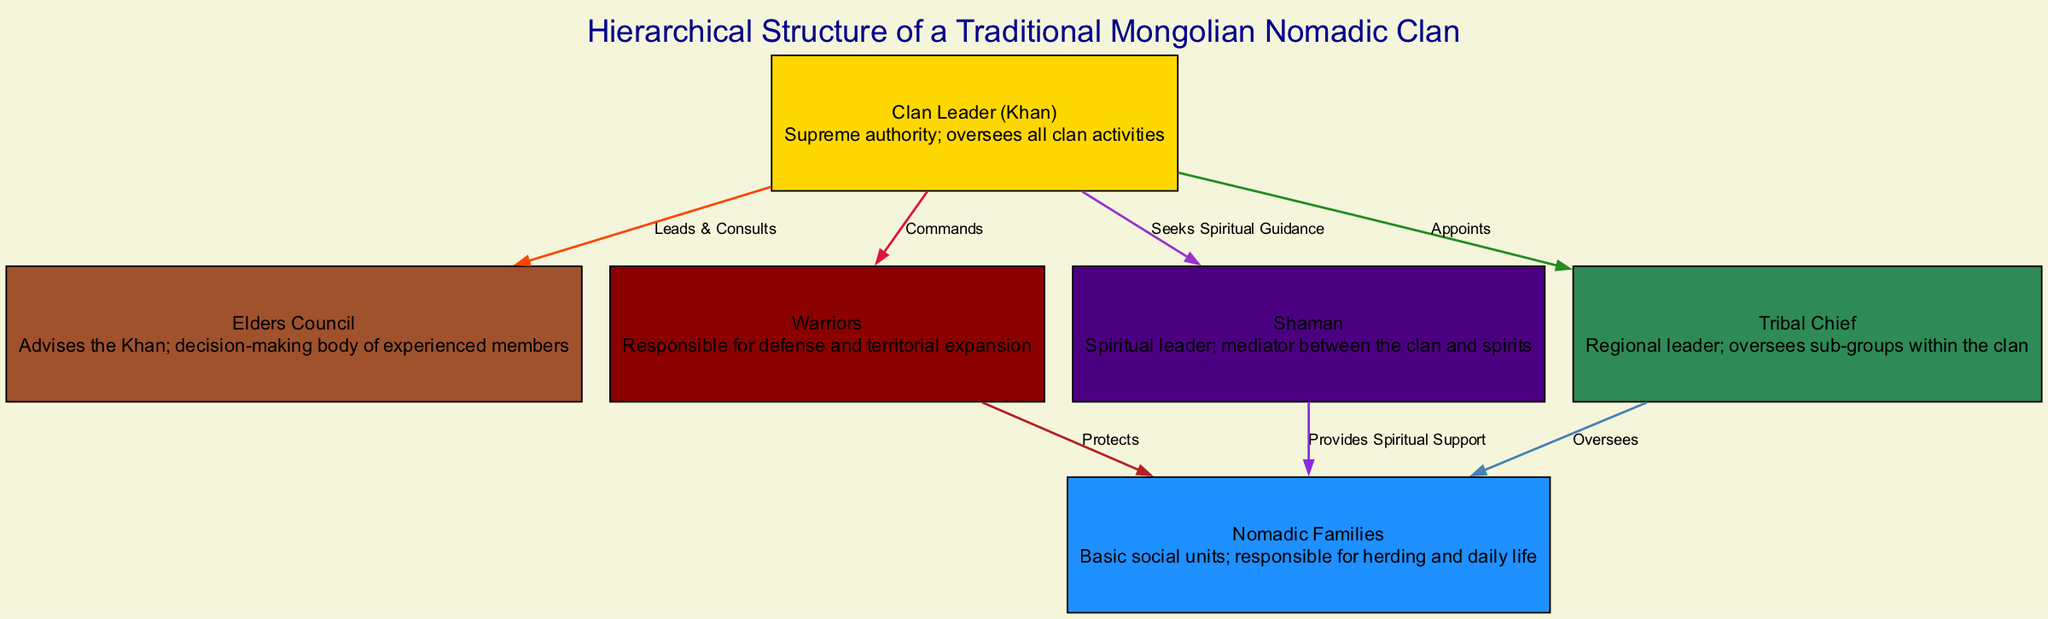What is the top node in the hierarchical structure? The top node in the diagram, which is the highest authority within the clan structure, is the Clan Leader (Khan).
Answer: Clan Leader (Khan) How many nodes represent roles in the clan? The diagram showcases a total of six unique roles within the clan, each represented by a separate node.
Answer: 6 Who provides spiritual support to the nomadic families? The Shaman, depicted in the diagram, is responsible for providing spiritual support to the nomadic families.
Answer: Shaman Which role is responsible for defense and territorial expansion? The Warriors are identified in the hierarchy as the group tasked with defense and expansion efforts for the clan.
Answer: Warriors What relationship exists between the Clan Leader and the Elders Council? The Clan Leader leads and consults with the Elders Council, making it a collaborative advisory relationship for decision-making.
Answer: Leads & Consults How does the Tribal Chief interact with the Nomadic Families? The Tribal Chief oversees the Nomadic Families, indicating a supervisory role over these basic social units within the clan.
Answer: Oversees What other role does the Clan Leader seek advice from? Apart from the Elders Council, the Clan Leader also seeks spiritual guidance from the Shaman, indicating a connection with the spiritual aspects of clan life.
Answer: Shaman How many edges illustrate relationships in the diagram? There are seven edges in the diagram that represent different types of relationships and interactions among the roles in the clan.
Answer: 7 